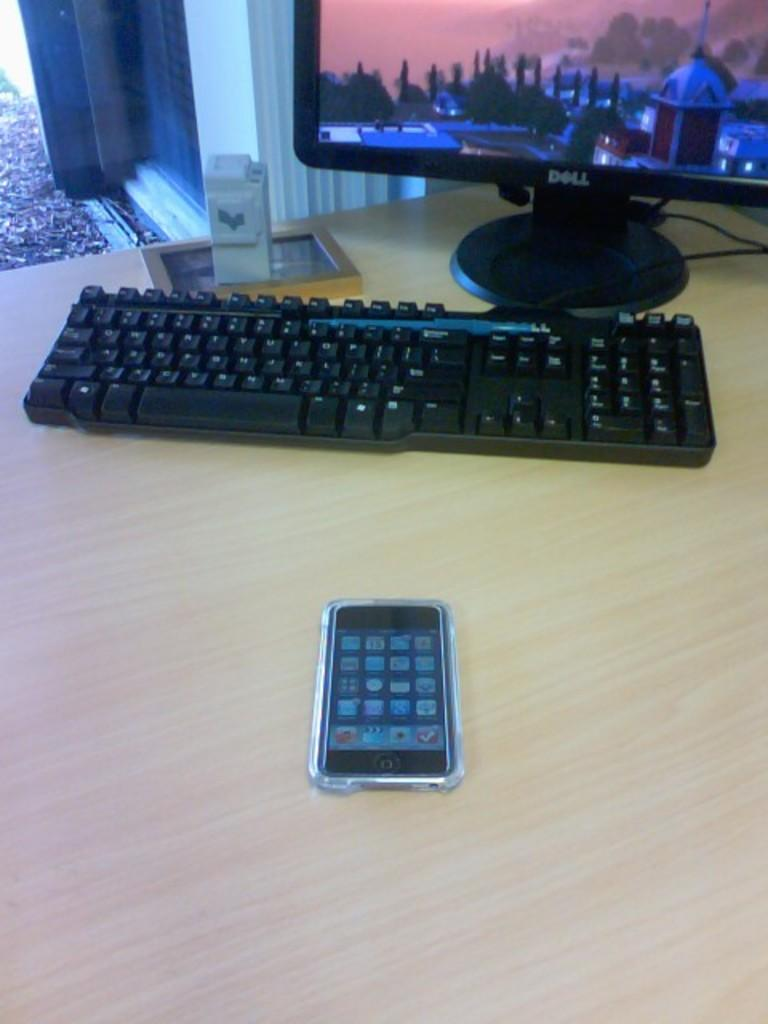What electronic device is visible in the image? There is a phone in the image. What other device is present in the image? There is a keyboard in the image. What is the third electronic device in the image? There is a monitor in the image. What type of basin is visible in the image? There is no basin present in the image. What word is written on the monitor in the image? The image does not show any specific words on the monitor, as it only depicts the monitor itself. 